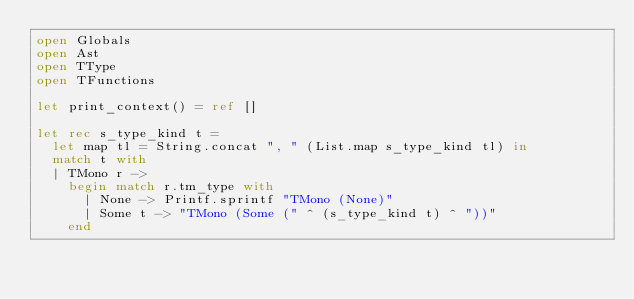Convert code to text. <code><loc_0><loc_0><loc_500><loc_500><_OCaml_>open Globals
open Ast
open TType
open TFunctions

let print_context() = ref []

let rec s_type_kind t =
	let map tl = String.concat ", " (List.map s_type_kind tl) in
	match t with
	| TMono r ->
		begin match r.tm_type with
			| None -> Printf.sprintf "TMono (None)"
			| Some t -> "TMono (Some (" ^ (s_type_kind t) ^ "))"
		end</code> 